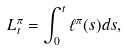<formula> <loc_0><loc_0><loc_500><loc_500>L _ { t } ^ { \pi } = \int _ { 0 } ^ { t } \ell ^ { \pi } ( s ) d s ,</formula> 